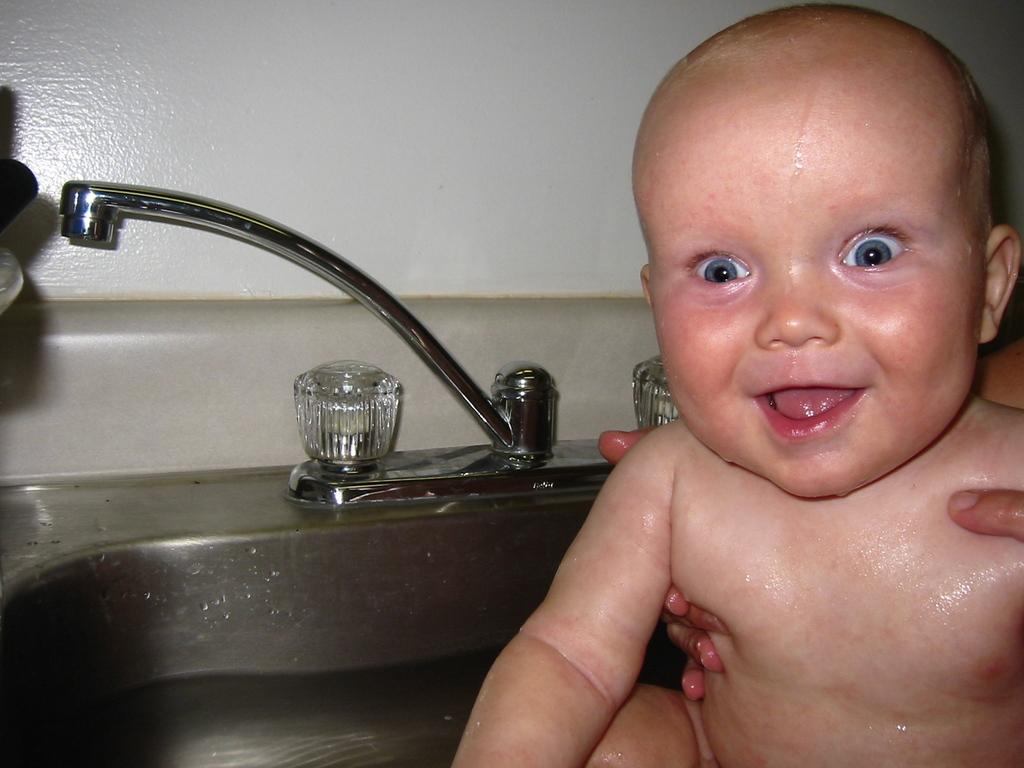How would you summarize this image in a sentence or two? In this image we can see there is a person's hand holding a baby in the water, behind the baby there is a tap and a wall. 